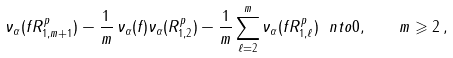<formula> <loc_0><loc_0><loc_500><loc_500>\nu _ { \alpha } ( f R _ { 1 , m + 1 } ^ { p } ) - \frac { 1 } { m } \, \nu _ { \alpha } ( f ) \nu _ { \alpha } ( R _ { 1 , 2 } ^ { p } ) - \frac { 1 } { m } \sum _ { \ell = 2 } ^ { m } \nu _ { \alpha } ( f R _ { 1 , \ell } ^ { p } ) \ n t o 0 , \quad m \geqslant 2 \, ,</formula> 